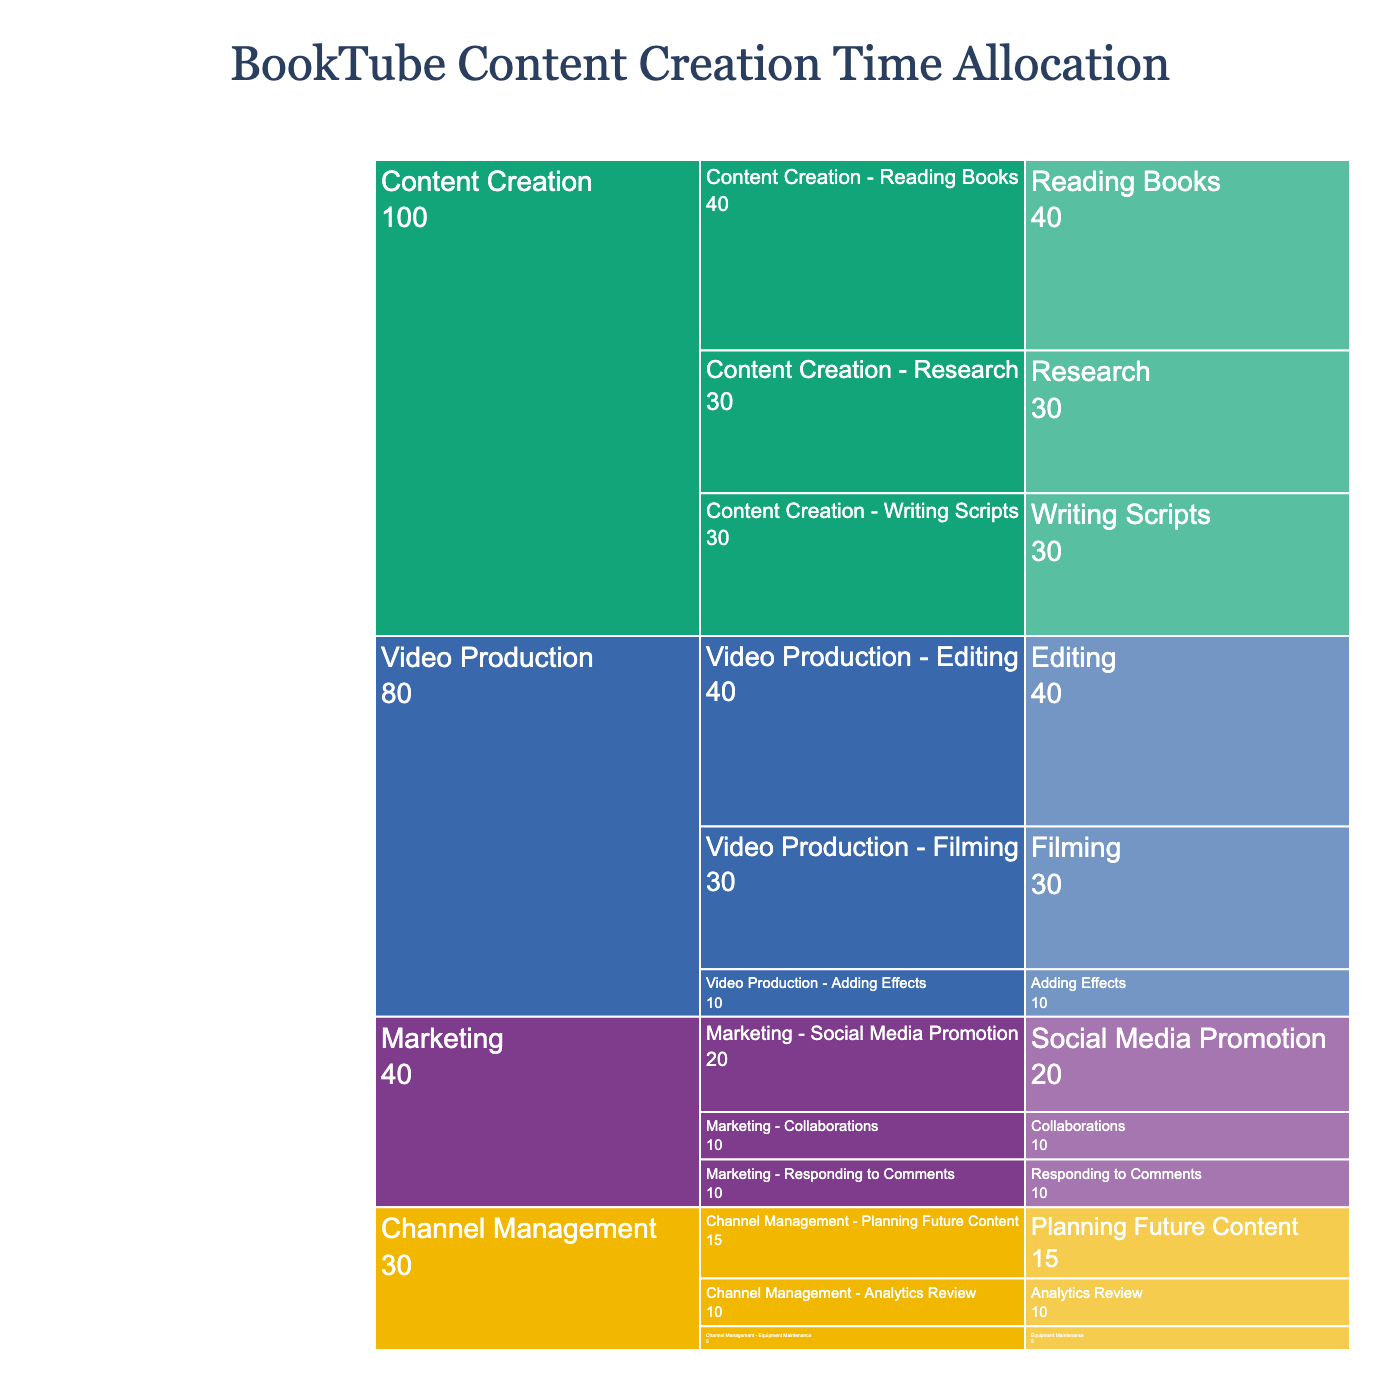How much time is allocated to Content Creation? The segment size representing Content Creation shows 100 hours allocated specifically to this task.
Answer: 100 hours Which subtask under Video Production takes the most time? The subtasks under Video Production are Filming (30 hours), Editing (40 hours), and Adding Effects (10 hours). Among these, Editing is the highest.
Answer: Editing How much total time is spent on Marketing? The segment size for Marketing shows 40 hours, including Social Media Promotion (20 hours), Collaborations (10 hours), and Responding to Comments (10 hours).
Answer: 40 hours Which task is given the least time, and how many hours are allocated to it? From the segments, Channel Management appears to have the least time allocated with a total of 30 hours.
Answer: Channel Management, 30 hours Compare the time spent on Reading Books and Filming. Which one takes more time and by how much? Reading Books takes 40 hours, and Filming takes 30 hours. Reading Books takes 10 hours more.
Answer: Reading Books, 10 hours What is the combined time for all subtasks under Channel Management? The subtasks for Channel Management are Analytics Review (10 hours), Planning Future Content (15 hours), and Equipment Maintenance (5 hours). Sum them up: 10 + 15 + 5 = 30 hours.
Answer: 30 hours Which subtask under Marketing takes the least time, and how many hours? The subtasks under Marketing include Social Media Promotion (20 hours), Collaborations (10 hours), and Responding to Comments (10 hours). Both Collaborations and Responding to Comments take 10 hours each.
Answer: Collaborations and Responding to Comments, 10 hours each What's the total duration for all subtasks under Content Creation? The subtasks for Content Creation are Reading Books (40 hours), Writing Scripts (30 hours), and Research (30 hours). Sum them up: 40 + 30 + 30 = 100 hours.
Answer: 100 hours What is the most time-consuming subtask, and how long does it take? By comparing all the subtasks, Editing under Video Production is the most time-consuming with 40 hours.
Answer: Editing, 40 hours 